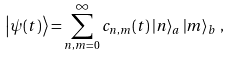<formula> <loc_0><loc_0><loc_500><loc_500>\left | \psi ( t ) \right > = \sum _ { n , m = 0 } ^ { \infty } c _ { n , m } ( t ) \left | n \right > _ { a } \left | m \right > _ { b } \, ,</formula> 